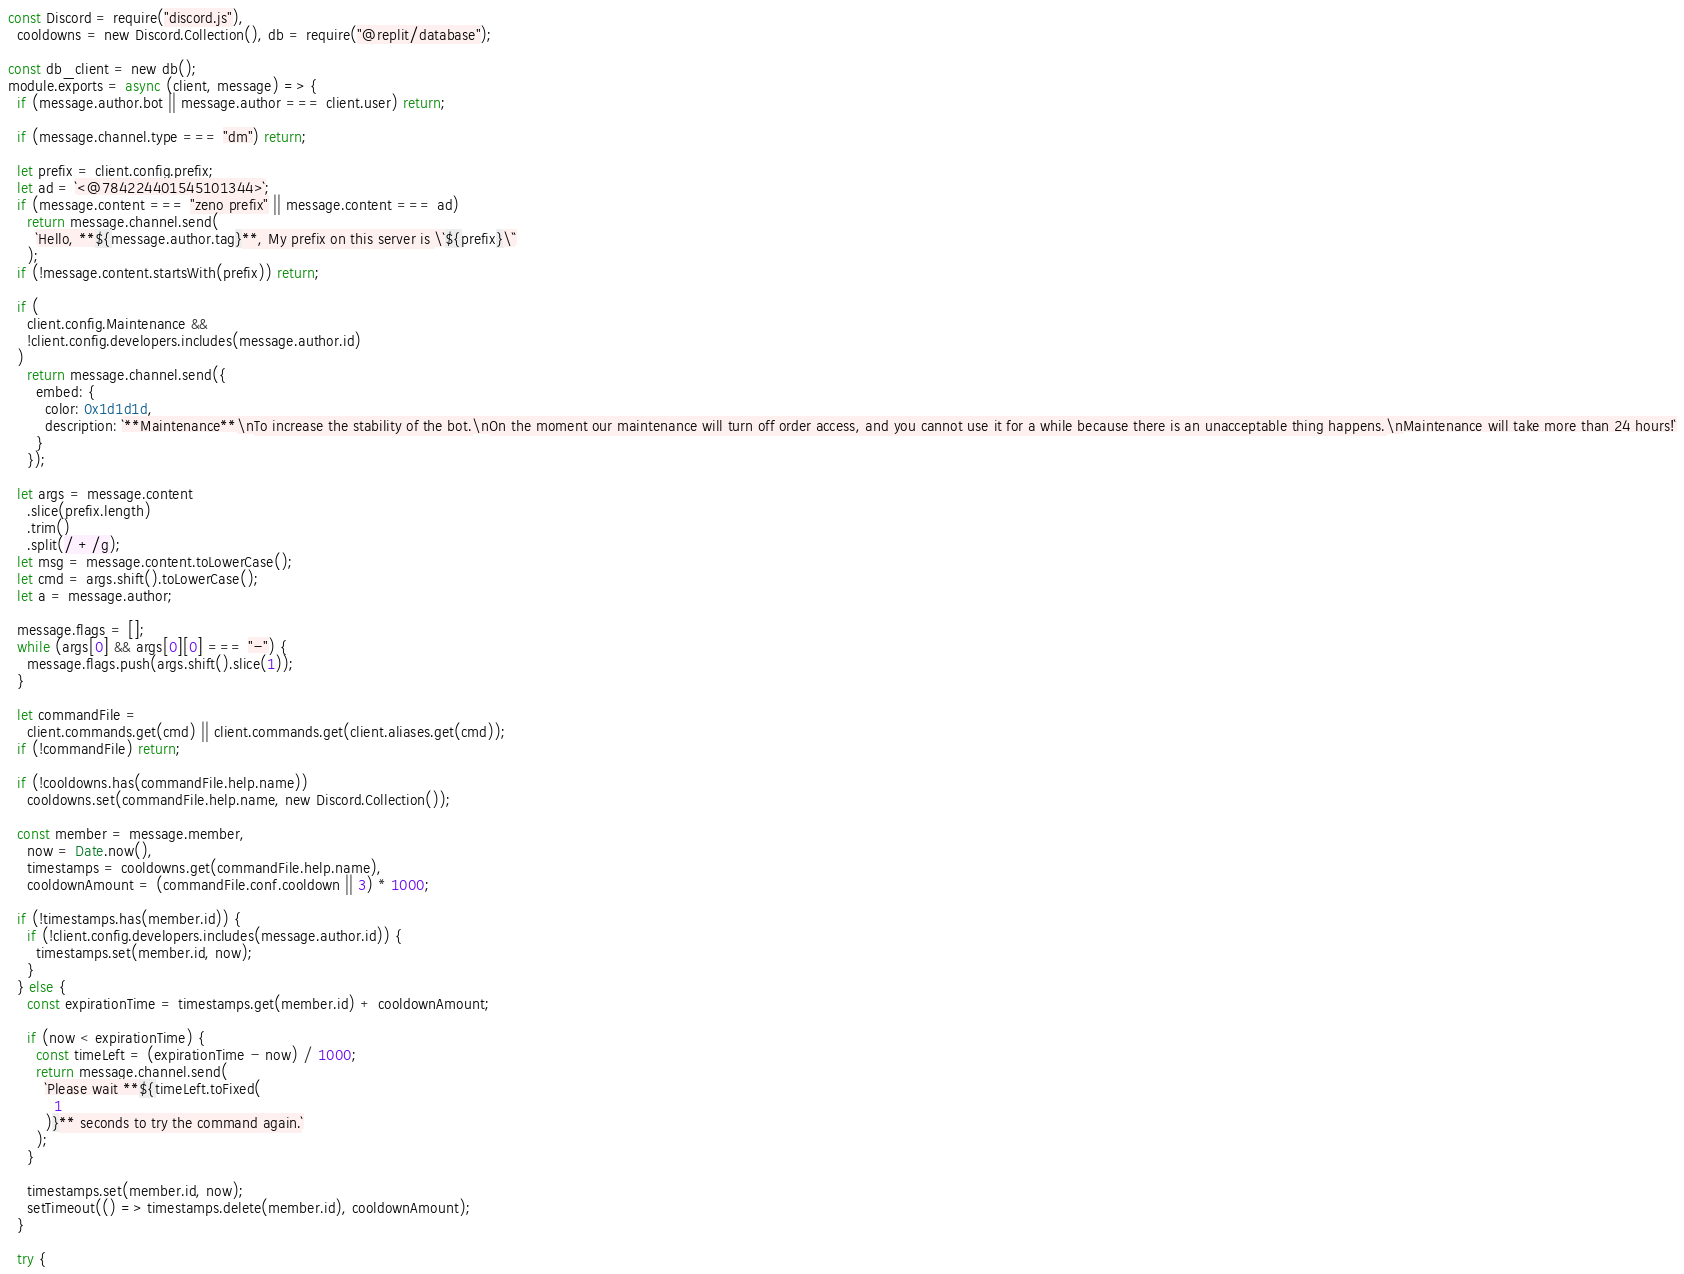Convert code to text. <code><loc_0><loc_0><loc_500><loc_500><_JavaScript_>const Discord = require("discord.js"),
  cooldowns = new Discord.Collection(), db = require("@replit/database");

const db_client = new db();
module.exports = async (client, message) => {
  if (message.author.bot || message.author === client.user) return;

  if (message.channel.type === "dm") return;

  let prefix = client.config.prefix;
  let ad = `<@784224401545101344>`;
  if (message.content === "zeno prefix" || message.content === ad)
    return message.channel.send(
      `Hello, **${message.author.tag}**, My prefix on this server is \`${prefix}\``
    );
  if (!message.content.startsWith(prefix)) return;

  if (
    client.config.Maintenance &&
    !client.config.developers.includes(message.author.id)
  )
    return message.channel.send({
      embed: {
        color: 0x1d1d1d,
        description: `**Maintenance**\nTo increase the stability of the bot.\nOn the moment our maintenance will turn off order access, and you cannot use it for a while because there is an unacceptable thing happens.\nMaintenance will take more than 24 hours!`
      }
    });

  let args = message.content
    .slice(prefix.length)
    .trim()
    .split(/ +/g);
  let msg = message.content.toLowerCase();
  let cmd = args.shift().toLowerCase();
  let a = message.author;

  message.flags = [];
  while (args[0] && args[0][0] === "-") {
    message.flags.push(args.shift().slice(1));
  }

  let commandFile =
    client.commands.get(cmd) || client.commands.get(client.aliases.get(cmd));
  if (!commandFile) return;

  if (!cooldowns.has(commandFile.help.name))
    cooldowns.set(commandFile.help.name, new Discord.Collection());

  const member = message.member,
    now = Date.now(),
    timestamps = cooldowns.get(commandFile.help.name),
    cooldownAmount = (commandFile.conf.cooldown || 3) * 1000;

  if (!timestamps.has(member.id)) {
    if (!client.config.developers.includes(message.author.id)) {
      timestamps.set(member.id, now);
    }
  } else {
    const expirationTime = timestamps.get(member.id) + cooldownAmount;

    if (now < expirationTime) {
      const timeLeft = (expirationTime - now) / 1000;
      return message.channel.send(
        `Please wait **${timeLeft.toFixed(
          1
        )}** seconds to try the command again.`
      );
    }

    timestamps.set(member.id, now);
    setTimeout(() => timestamps.delete(member.id), cooldownAmount);
  }

  try {</code> 